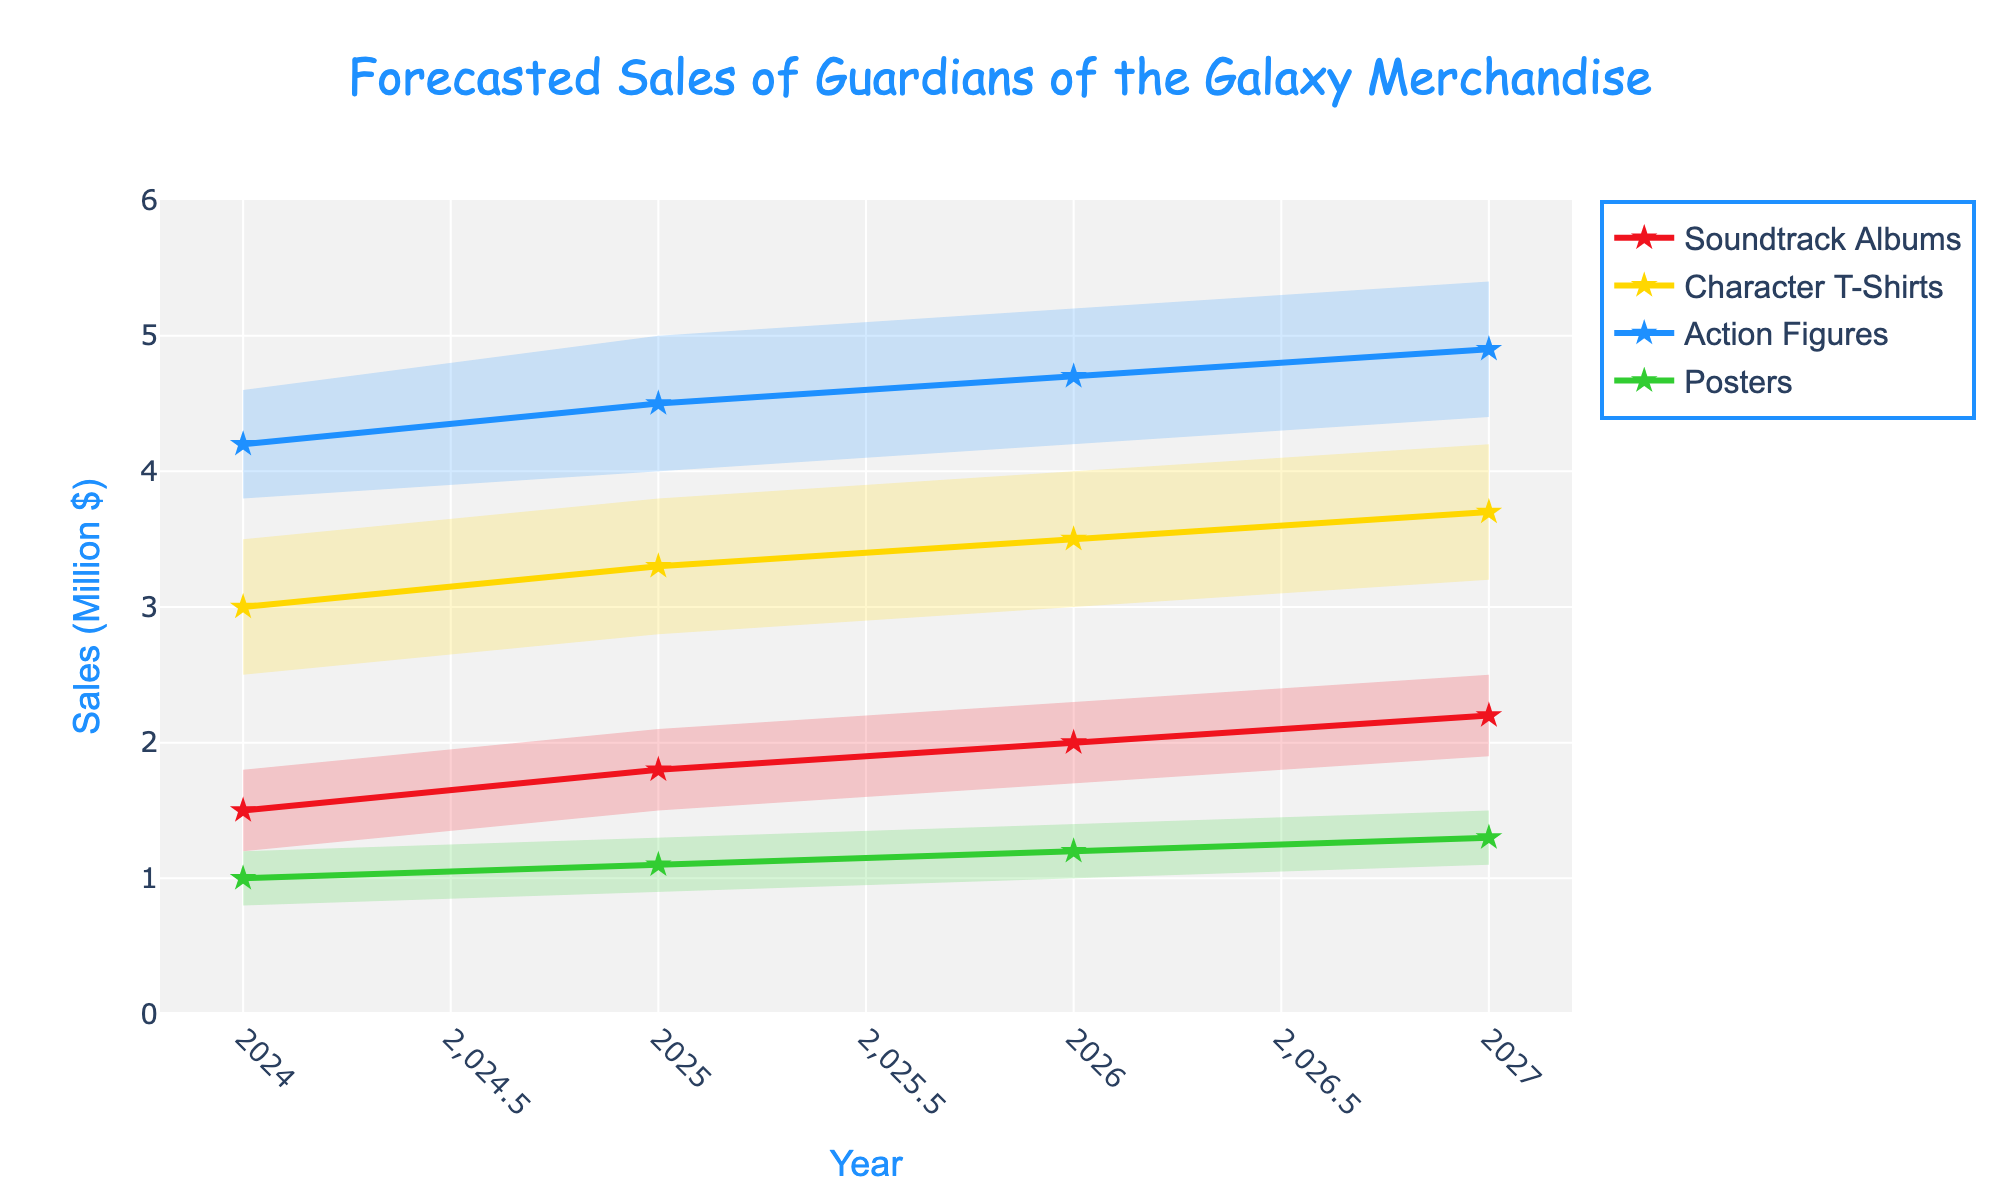What's the title of the plot? The title is written at the top of the plot and uses a specific font and color.
Answer: Forecasted Sales of Guardians of the Galaxy Merchandise What are the sales forecast ranges for Character T-Shirts in 2024? The plot includes uncertainty ranges for each category in each year, shown as shaded areas. For Character T-Shirts in 2024, the low end of the range is $2.5M, the mid value is $3.0M, and the high end of the range is $3.5M.
Answer: $2.5M to $3.5M Which category experienced the greatest increase in mid-value sales from 2024 to 2027? By examining the mid-values for each category in both 2024 and 2027, we find the differences. For Soundtrack Albums, it's 2.2M - 1.5M = 0.7M; for Character T-Shirts, it's 3.7M - 3.0M = 0.7M; for Action Figures, it's 4.9M - 4.2M = 0.7M; for Posters, it's 1.3M - 1.0M = 0.3M.
Answer: Tie between Soundtrack Albums, Character T-Shirts, and Action Figures, with a 0.7M increase each What is the average mid-value forecast for Posters from 2024 to 2027? The mid-values for Posters are 1.0M (2024), 1.1M (2025), 1.2M (2026), and 1.3M (2027). The average is calculated as (1.0 + 1.1 + 1.2 + 1.3) / 4 = 1.15M.
Answer: 1.15M In which year is the range of forecasted sales for Action Figures the widest? The range for each year is the difference between the high and low values. For Action Figures: 
2024: 4.6M - 3.8M = 0.8M
2025: 5.0M - 4.0M = 1.0M
2026: 5.2M - 4.2M = 1.0M
2027: 5.4M - 4.4M = 1.0M
The widest range is 1.0M and occurs in 2025, 2026, and 2027.
Answer: 2025, 2026, and 2027 Compare the sales forecast for Soundtrack Albums and Action Figures in 2026. Which category is expected to have higher mid-value sales, and by how much? Soundtrack Albums in 2026 have a mid-value of 2.0M while Action Figures have a mid-value of 4.7M. The difference is 4.7M - 2.0M = 2.7M.
Answer: Action Figures by 2.7M How does the forecasted sales range for Posters in 2027 compare to the range in 2024? The range for Posters in 2027 is 1.5M - 1.1M = 0.4M and in 2024 it is 1.2M - 0.8M = 0.4M. Both ranges are the same.
Answer: The ranges are the same What's the trend for the mid-value sales of Character T-Shirts from 2024 to 2027? The mid-value sales for Character T-Shirts are 3.0M (2024), 3.3M (2025), 3.5M (2026), and 3.7M (2027). Each year shows a steady increase.
Answer: Increasing What is the total mid-value forecast for all categories in 2025? The mid-values for each category in 2025 are: 
Soundtrack Albums: 1.8M 
Character T-Shirts: 3.3M 
Action Figures: 4.5M 
Posters: 1.1M 
The total is 1.8 + 3.3 + 4.5 + 1.1 = 10.7M.
Answer: 10.7M 